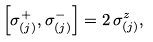<formula> <loc_0><loc_0><loc_500><loc_500>\left [ \sigma _ { ( j ) } ^ { + } , \sigma _ { ( j ) } ^ { - } \right ] = 2 \, \sigma _ { ( j ) } ^ { z } ,</formula> 